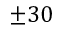Convert formula to latex. <formula><loc_0><loc_0><loc_500><loc_500>\pm 3 0</formula> 